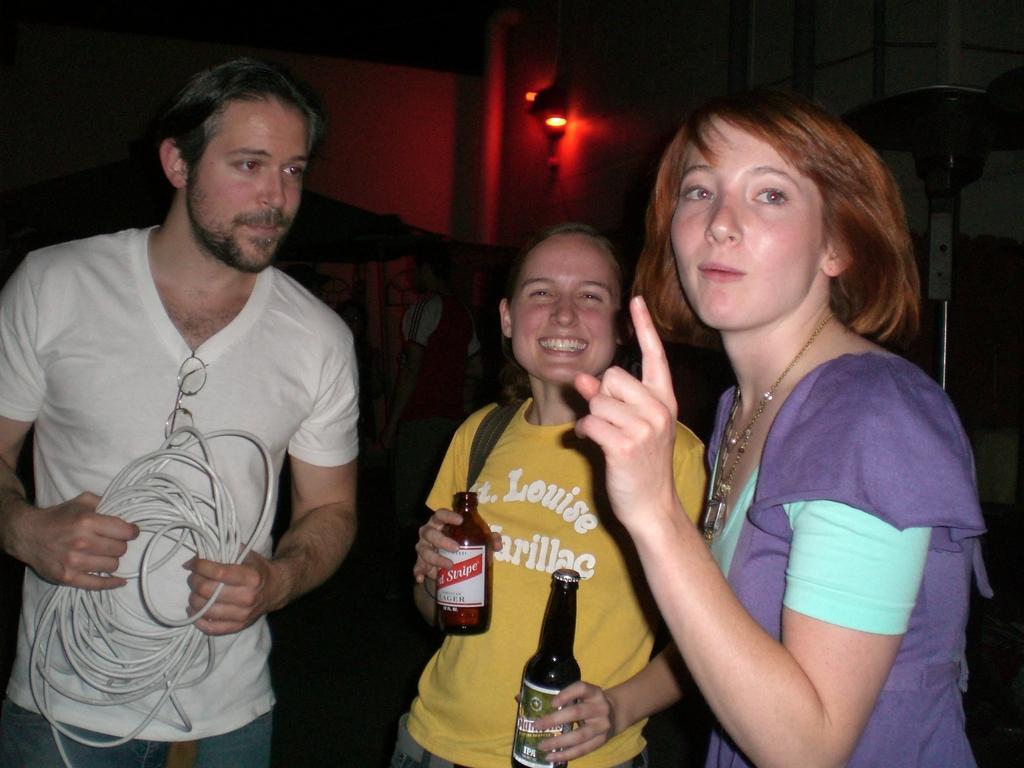Describe this image in one or two sentences. On the left hand side, there is a person in white color t-shirt holding a cable. Beside him, there are two women. One of them in yellow color t-shirt holding two bottles. And other one is in violet color t-shirt smiling. In the background, there is pink color wall and a light. 